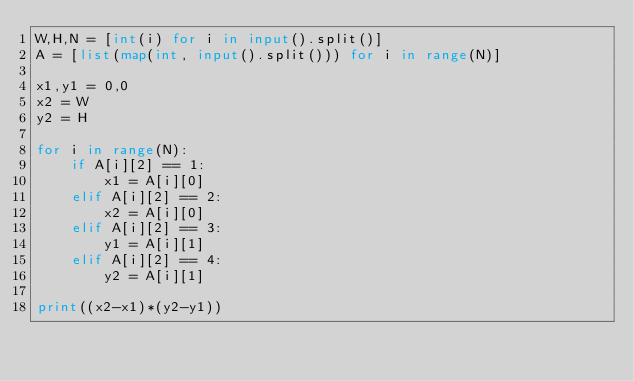Convert code to text. <code><loc_0><loc_0><loc_500><loc_500><_Python_>W,H,N = [int(i) for i in input().split()]
A = [list(map(int, input().split())) for i in range(N)]

x1,y1 = 0,0
x2 = W
y2 = H

for i in range(N):
    if A[i][2] == 1:
        x1 = A[i][0]
    elif A[i][2] == 2:
        x2 = A[i][0]
    elif A[i][2] == 3:
        y1 = A[i][1]
    elif A[i][2] == 4:
        y2 = A[i][1]

print((x2-x1)*(y2-y1))
</code> 